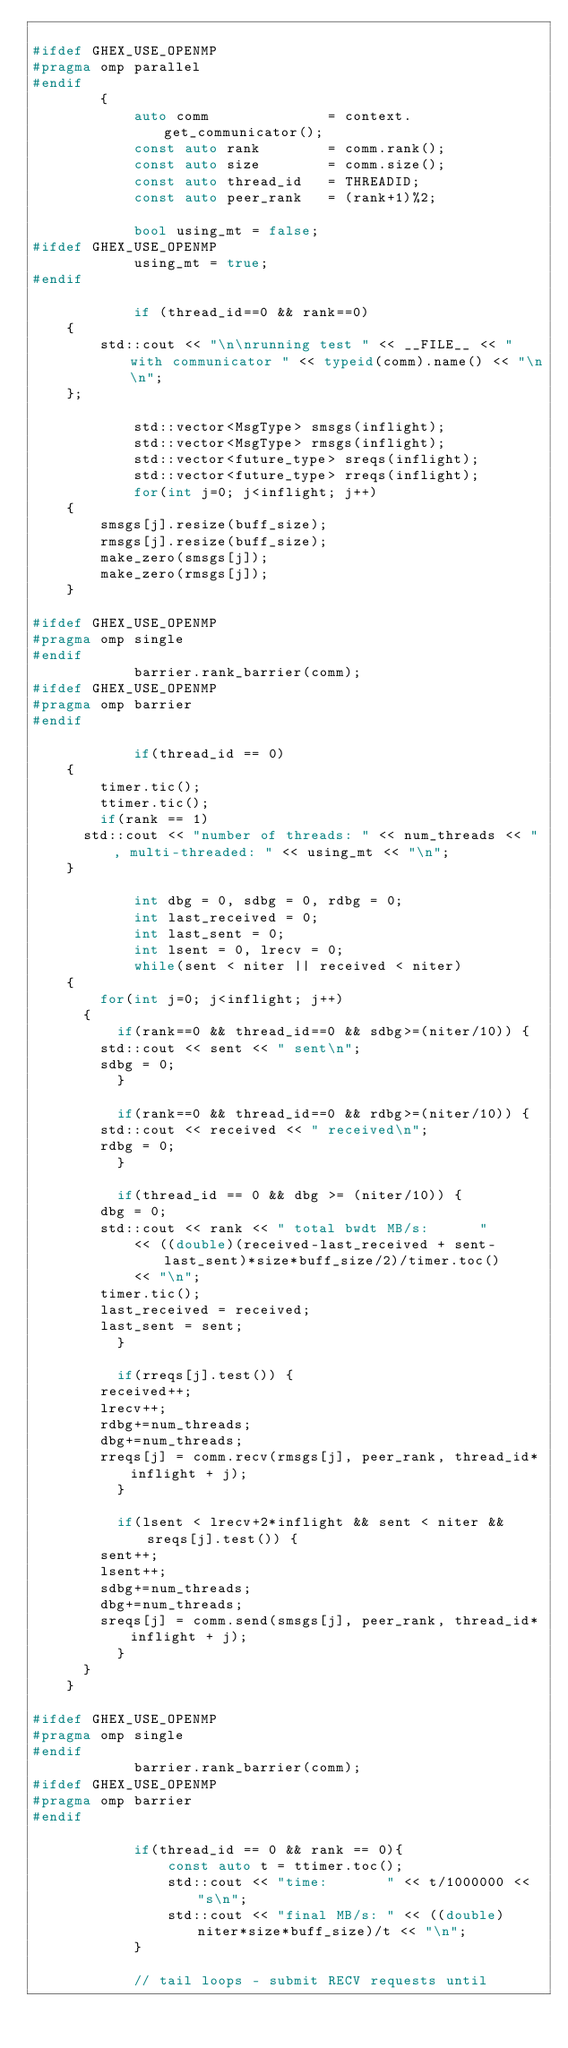<code> <loc_0><loc_0><loc_500><loc_500><_C++_>
#ifdef GHEX_USE_OPENMP
#pragma omp parallel
#endif
        {
            auto comm              = context.get_communicator();
            const auto rank        = comm.rank();
            const auto size        = comm.size();
            const auto thread_id   = THREADID;
            const auto peer_rank   = (rank+1)%2;

            bool using_mt = false;
#ifdef GHEX_USE_OPENMP
            using_mt = true;
#endif

            if (thread_id==0 && rank==0)
		{
		    std::cout << "\n\nrunning test " << __FILE__ << " with communicator " << typeid(comm).name() << "\n\n";
		};

            std::vector<MsgType> smsgs(inflight);
            std::vector<MsgType> rmsgs(inflight);
            std::vector<future_type> sreqs(inflight);
            std::vector<future_type> rreqs(inflight);
            for(int j=0; j<inflight; j++)
		{
		    smsgs[j].resize(buff_size);
		    rmsgs[j].resize(buff_size);
		    make_zero(smsgs[j]);
		    make_zero(rmsgs[j]);
		}

#ifdef GHEX_USE_OPENMP
#pragma omp single
#endif
            barrier.rank_barrier(comm);
#ifdef GHEX_USE_OPENMP
#pragma omp barrier
#endif

            if(thread_id == 0)
		{
		    timer.tic();
		    ttimer.tic();
		    if(rank == 1)
			std::cout << "number of threads: " << num_threads << ", multi-threaded: " << using_mt << "\n";
		}

            int dbg = 0, sdbg = 0, rdbg = 0;
            int last_received = 0;
            int last_sent = 0;
            int lsent = 0, lrecv = 0;       
            while(sent < niter || received < niter)
		{
		    for(int j=0; j<inflight; j++)
			{
			    if(rank==0 && thread_id==0 && sdbg>=(niter/10)) {
				std::cout << sent << " sent\n";
				sdbg = 0;
			    }

			    if(rank==0 && thread_id==0 && rdbg>=(niter/10)) {
				std::cout << received << " received\n";
				rdbg = 0;
			    }

			    if(thread_id == 0 && dbg >= (niter/10)) {
				dbg = 0;
				std::cout << rank << " total bwdt MB/s:      "
					  << ((double)(received-last_received + sent-last_sent)*size*buff_size/2)/timer.toc()
					  << "\n";
				timer.tic();
				last_received = received;
				last_sent = sent;
			    }

			    if(rreqs[j].test()) {
				received++;
				lrecv++;
				rdbg+=num_threads;
				dbg+=num_threads;
				rreqs[j] = comm.recv(rmsgs[j], peer_rank, thread_id*inflight + j);
			    }

			    if(lsent < lrecv+2*inflight && sent < niter && sreqs[j].test()) {
				sent++;
				lsent++;
				sdbg+=num_threads;
				dbg+=num_threads;
				sreqs[j] = comm.send(smsgs[j], peer_rank, thread_id*inflight + j);
			    }
			}
		}

#ifdef GHEX_USE_OPENMP
#pragma omp single
#endif
            barrier.rank_barrier(comm);
#ifdef GHEX_USE_OPENMP
#pragma omp barrier
#endif

            if(thread_id == 0 && rank == 0){
                const auto t = ttimer.toc();
                std::cout << "time:       " << t/1000000 << "s\n";
                std::cout << "final MB/s: " << ((double)niter*size*buff_size)/t << "\n";
            }

            // tail loops - submit RECV requests until</code> 